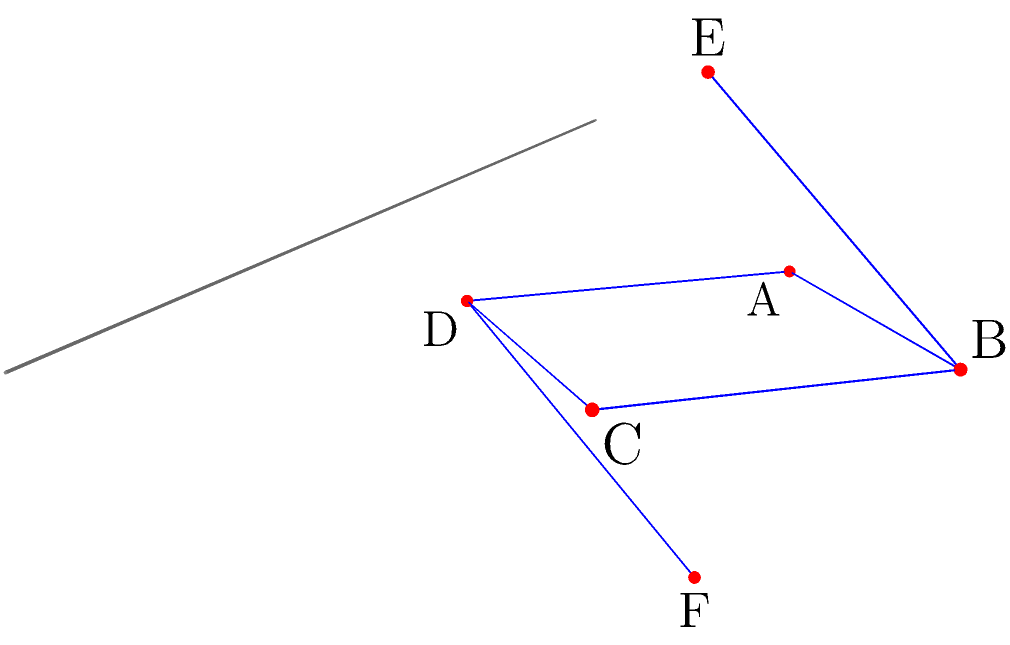In the given protein structure, identify the number of symmetry planes present. Describe the orientation of the primary symmetry plane. To identify symmetry planes in a protein structure, we need to analyze the arrangement of atoms or structural elements. Let's approach this step-by-step:

1. Observe the overall structure:
   The protein structure consists of 6 points (A, B, C, D, E, F) arranged in a 3D space.

2. Identify potential symmetry:
   The structure appears to have a planar arrangement (ABCD) with two additional points (E and F) above and below this plane.

3. Analyze the planar arrangement (ABCD):
   - It forms a rhombus shape in the XY plane.
   - The diagonals AC and BD intersect at the center.

4. Consider the points E and F:
   - They are equidistant from the ABCD plane and opposite to each other.

5. Identify symmetry planes:
   a) YZ plane: This plane bisects the structure through points B and D, dividing it into two mirror halves.
   b) XZ plane: This plane bisects the structure through points A and C, also dividing it into two mirror halves.
   c) XY plane: This plane (ABCD) acts as a mirror for points E and F.

6. Primary symmetry plane:
   The YZ plane (shown in the diagram) can be considered the primary symmetry plane as it bisects the structure through its longest axis.

Therefore, there are 3 symmetry planes in total, with the primary one being the YZ plane, oriented vertically and passing through points B and D.
Answer: 3 planes; YZ plane through B and D 